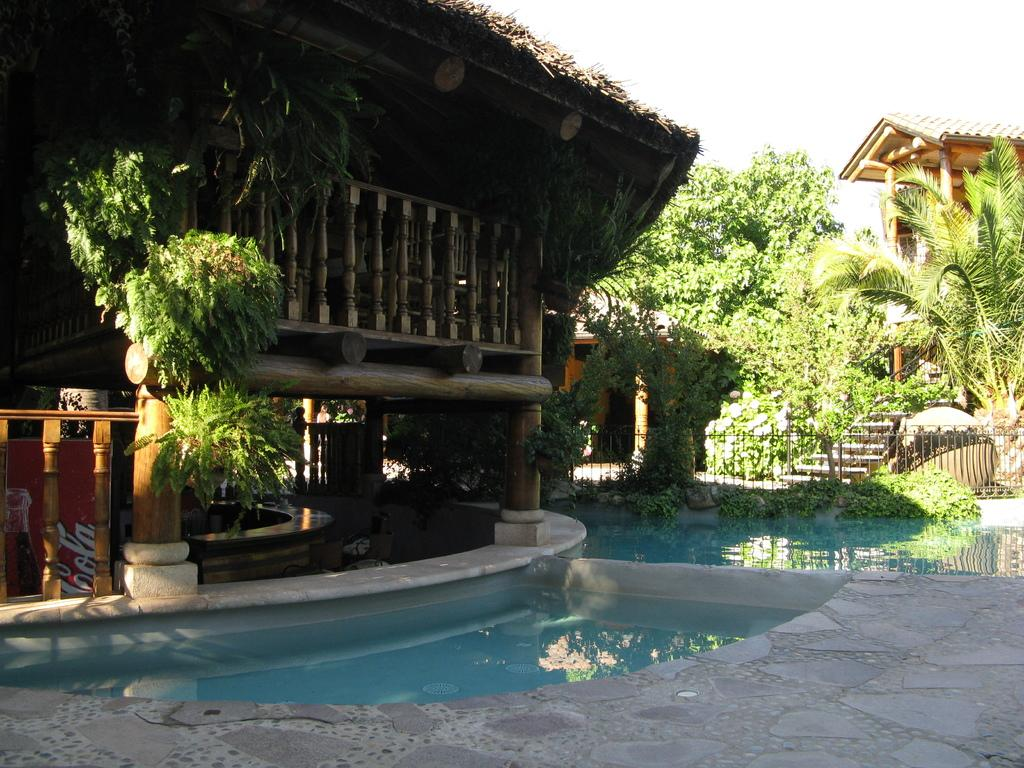What type of building is shown in the image? There is a house in the image. What feature is present near the house? There is a pool in the image. What type of vegetation can be seen in the image? Creepers are present in the image. What architectural element is visible in the image? There is an iron grill in the image. What part of the house can be seen in the image? The floor is visible in the image. What part of the natural environment is visible in the image? The sky is visible in the image. What type of prison can be seen in the image? There is no prison present in the image; it features a house, pool, creepers, iron grill, floor, and sky. What type of coach or carriage is visible in the image? There is no coach or carriage present in the image. 